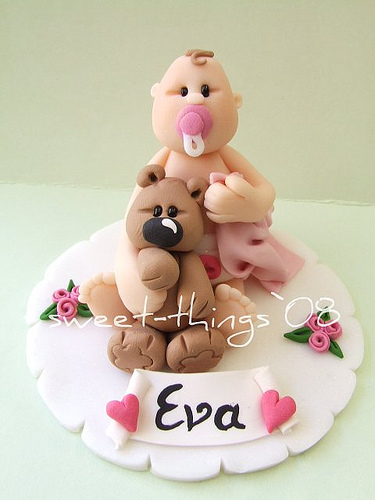Identify the text displayed in this image. Eva sweet-things 08 